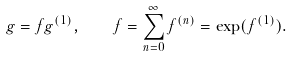Convert formula to latex. <formula><loc_0><loc_0><loc_500><loc_500>g = f g ^ { ( 1 ) } , \quad f = \sum _ { n = 0 } ^ { \infty } f ^ { ( n ) } = \exp ( f ^ { ( 1 ) } ) .</formula> 